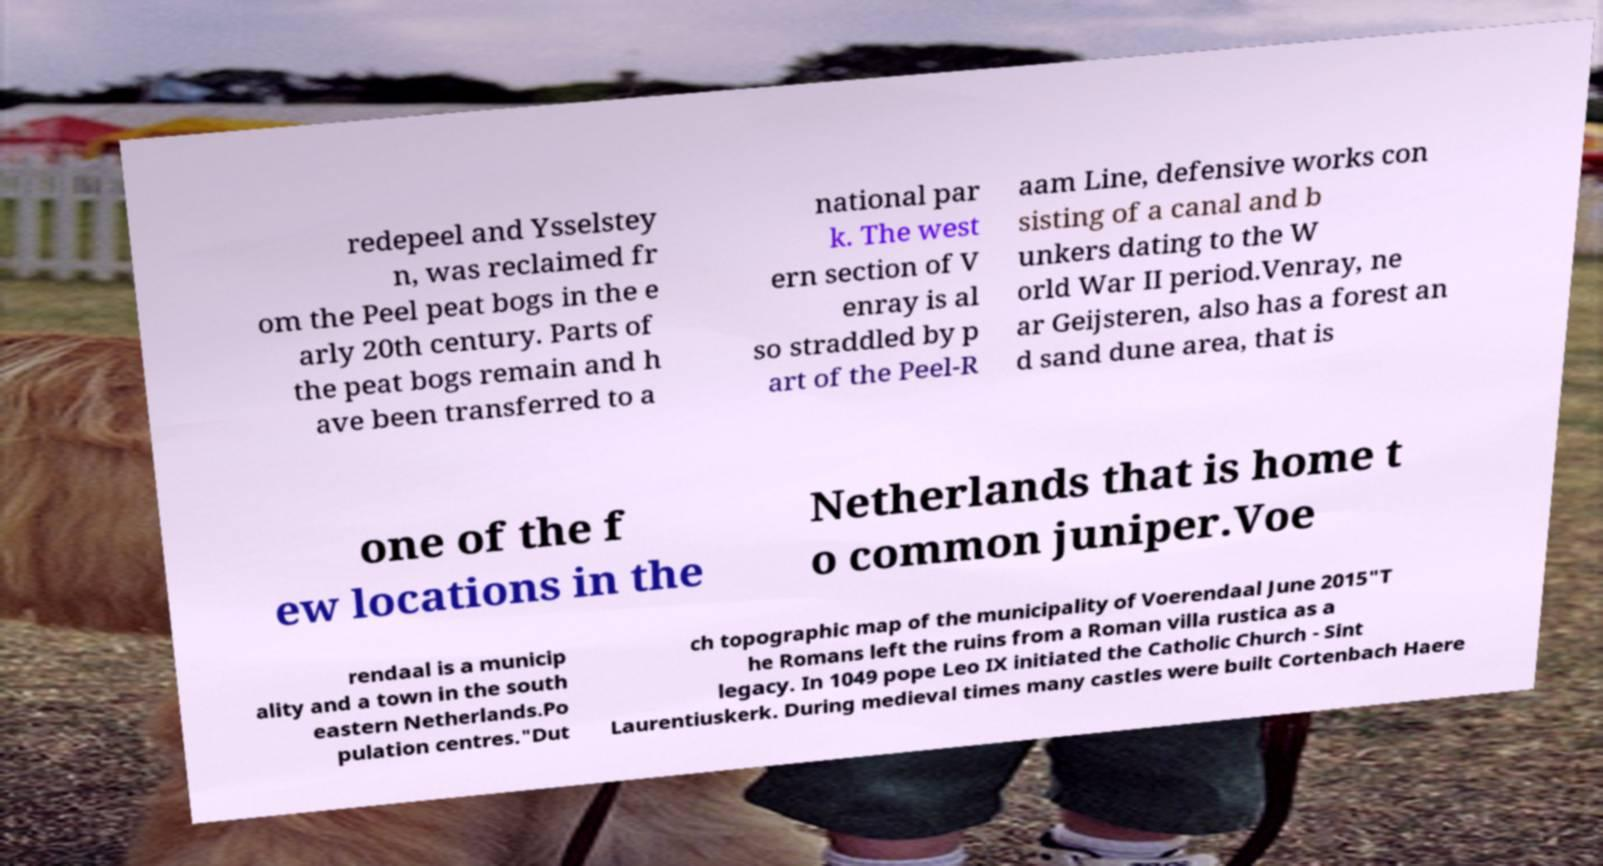Please read and relay the text visible in this image. What does it say? redepeel and Ysselstey n, was reclaimed fr om the Peel peat bogs in the e arly 20th century. Parts of the peat bogs remain and h ave been transferred to a national par k. The west ern section of V enray is al so straddled by p art of the Peel-R aam Line, defensive works con sisting of a canal and b unkers dating to the W orld War II period.Venray, ne ar Geijsteren, also has a forest an d sand dune area, that is one of the f ew locations in the Netherlands that is home t o common juniper.Voe rendaal is a municip ality and a town in the south eastern Netherlands.Po pulation centres."Dut ch topographic map of the municipality of Voerendaal June 2015"T he Romans left the ruins from a Roman villa rustica as a legacy. In 1049 pope Leo IX initiated the Catholic Church - Sint Laurentiuskerk. During medieval times many castles were built Cortenbach Haere 